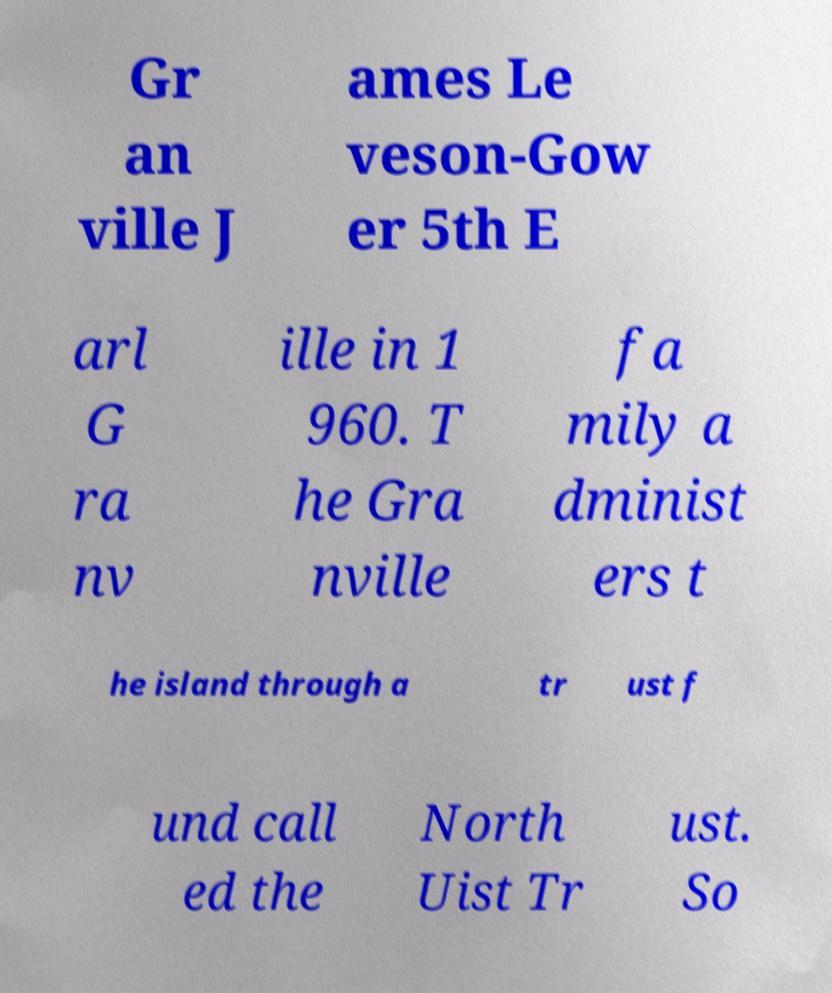There's text embedded in this image that I need extracted. Can you transcribe it verbatim? Gr an ville J ames Le veson-Gow er 5th E arl G ra nv ille in 1 960. T he Gra nville fa mily a dminist ers t he island through a tr ust f und call ed the North Uist Tr ust. So 